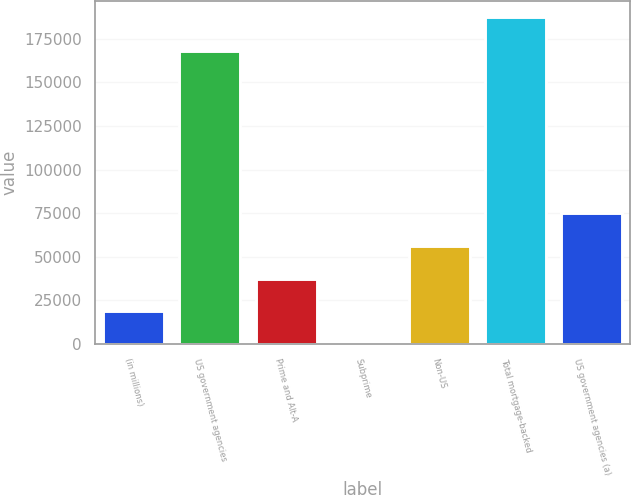Convert chart to OTSL. <chart><loc_0><loc_0><loc_500><loc_500><bar_chart><fcel>(in millions)<fcel>US government agencies<fcel>Prime and Alt-A<fcel>Subprime<fcel>Non-US<fcel>Total mortgage-backed<fcel>US government agencies (a)<nl><fcel>18743.9<fcel>167898<fcel>37470.8<fcel>17<fcel>56197.7<fcel>187286<fcel>74924.6<nl></chart> 